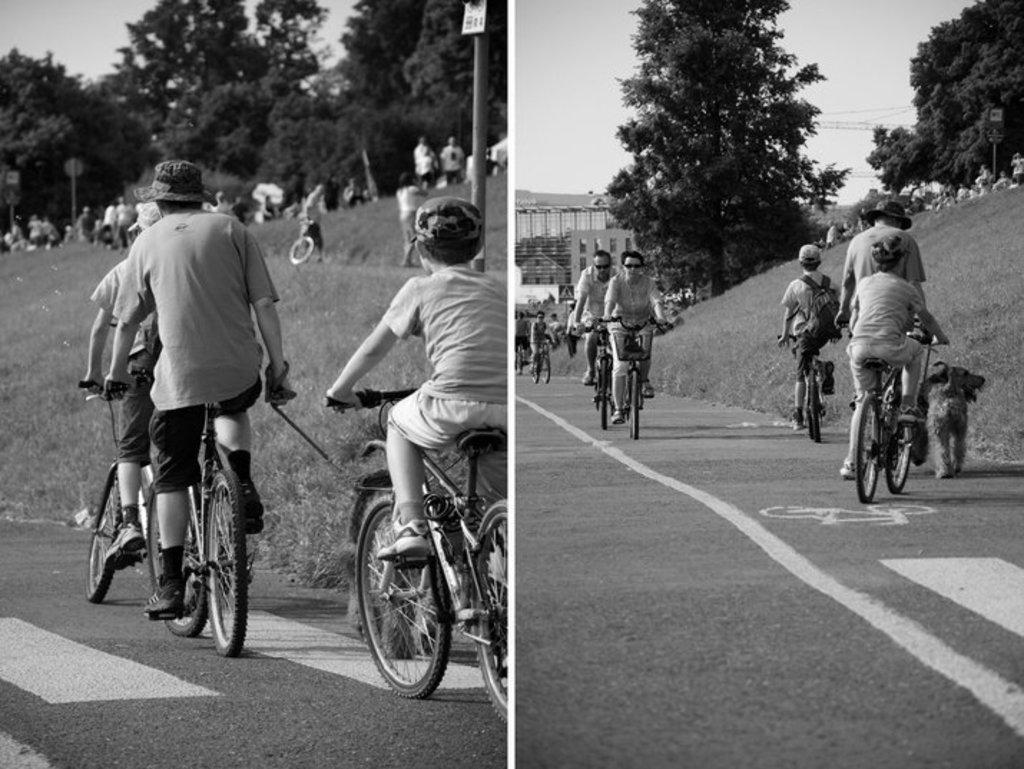Describe this image in one or two sentences. To the left side picture there are boys riding a bicycle on the road. And in the right side picture there are few people riding bicycle on the road. And a dog is on the road. In both the pictures there are trees in the background. And few people are there on the hill. 